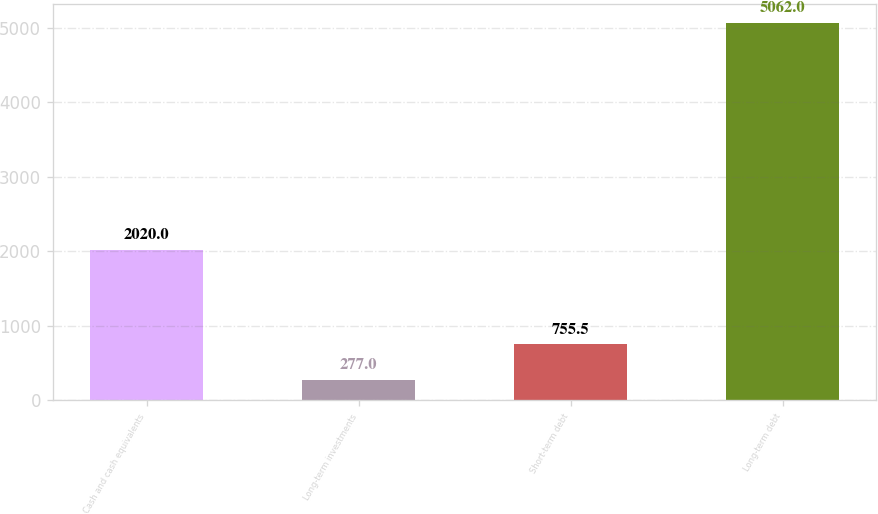Convert chart to OTSL. <chart><loc_0><loc_0><loc_500><loc_500><bar_chart><fcel>Cash and cash equivalents<fcel>Long-term investments<fcel>Short-term debt<fcel>Long-term debt<nl><fcel>2020<fcel>277<fcel>755.5<fcel>5062<nl></chart> 